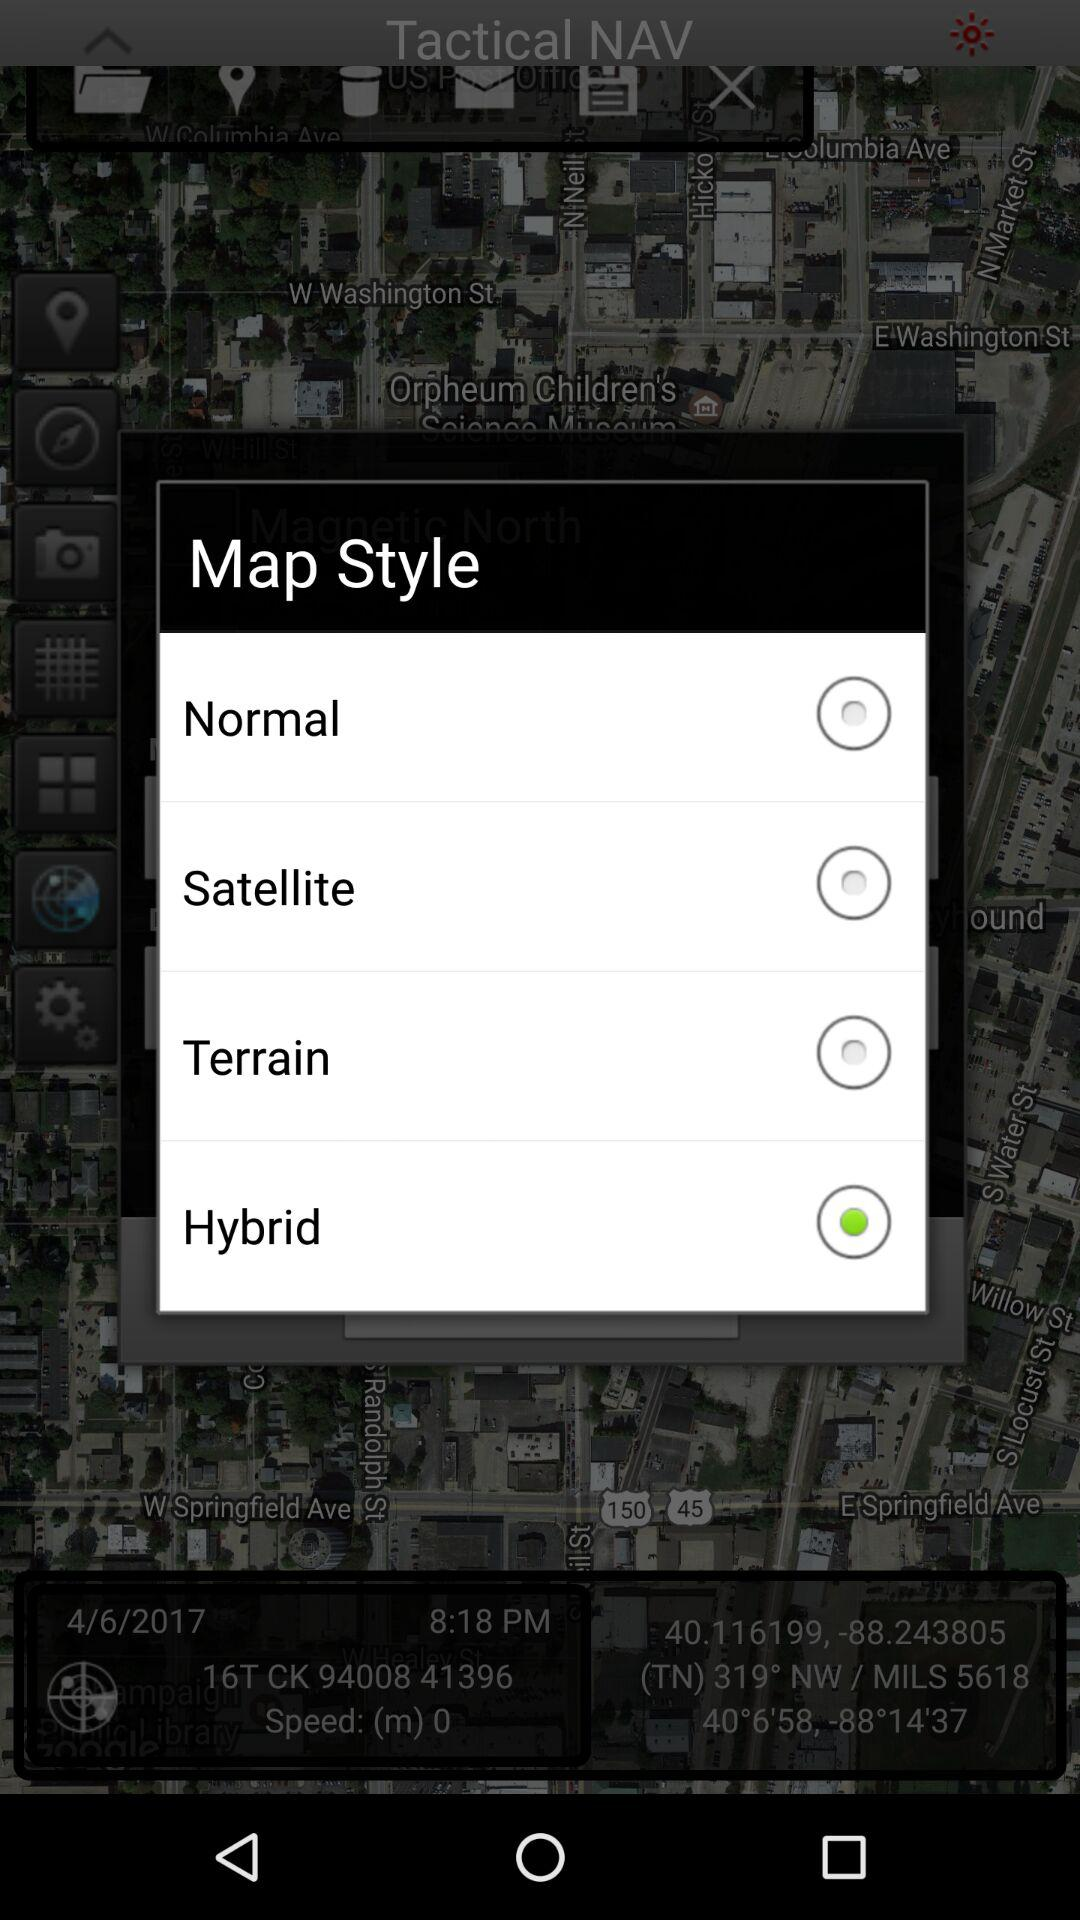What are the different types of map styles? The different types are "Normal", "Satellite", "Terrain", and "Hybrid". 